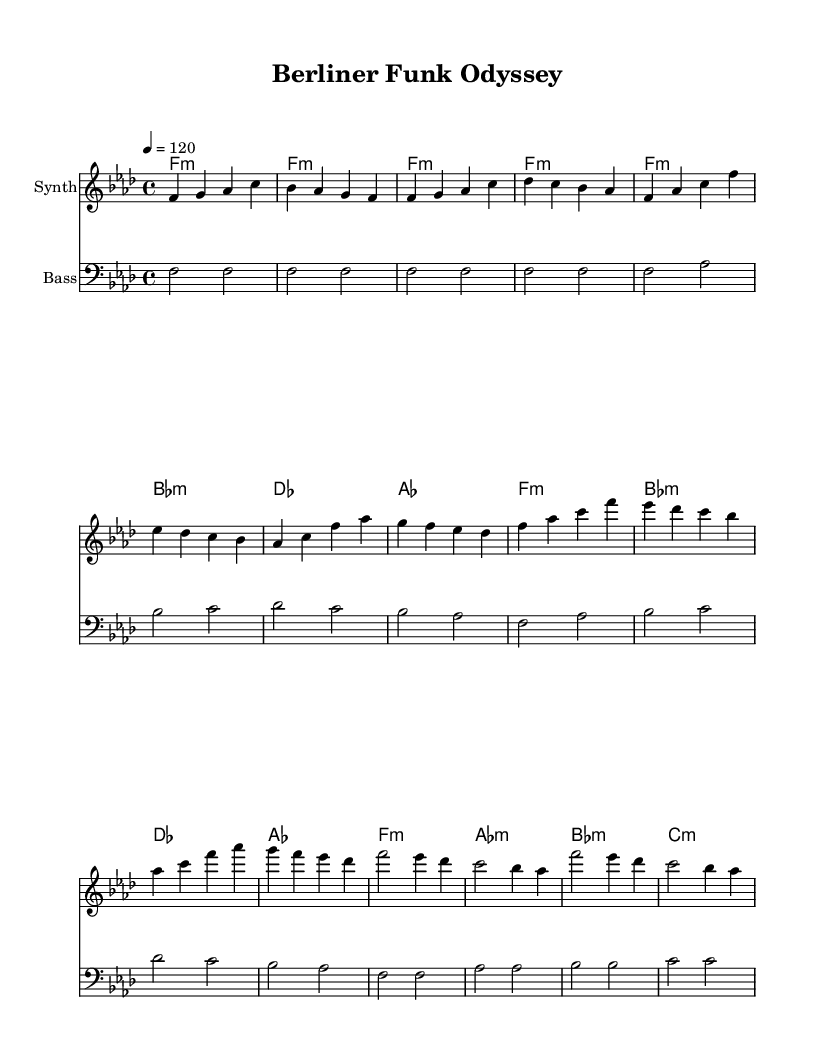What is the key signature of this music? The key signature is indicated by the sharp or flat symbols on the staff. In this case, there are four flats (B, E, A, and D), which means the key is F minor.
Answer: F minor What is the time signature of this music? The time signature is located at the beginning of the piece and shows how many beats are in each measure. It is 4/4, meaning there are 4 beats per measure.
Answer: 4/4 What is the tempo marking of this piece? The tempo marking is shown at the beginning of the sheet music as a metronome marking, which indicates the speed of the piece. Here it's marked as "4 = 120".
Answer: 120 How many measures are present in the synth melody? By counting the measures in the synth melody section, we can observe that there are a total of 16 measures.
Answer: 16 Which chord is played at the beginning of the music? The first chord is indicated in the chord names section. The first chord listed is f minor.
Answer: f minor What is the primary musical style reflected in this piece? The structure, use of synth elements, and the overall rhythmic groove reflect characteristics of Funk-infused electronic music, which is popular in underground clubs.
Answer: Funk-infused electronic music What is the last chord played in the piece? By examining the final chord name in the chord progressions, we can see that the last chord listed is c minor.
Answer: c minor 